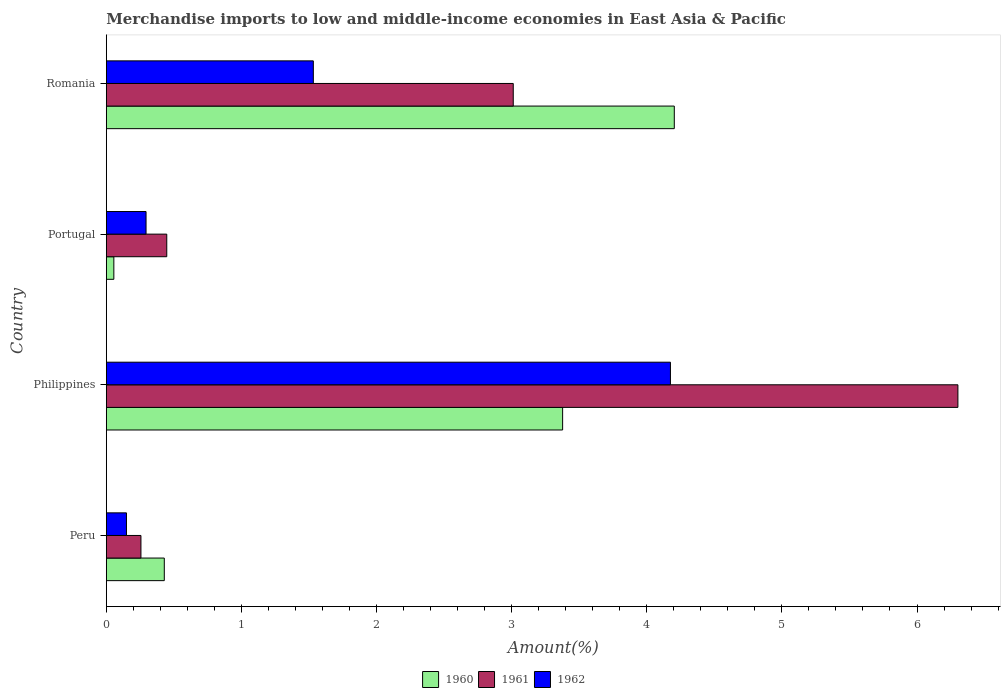How many different coloured bars are there?
Provide a short and direct response. 3. How many groups of bars are there?
Give a very brief answer. 4. Are the number of bars per tick equal to the number of legend labels?
Give a very brief answer. Yes. Are the number of bars on each tick of the Y-axis equal?
Your answer should be very brief. Yes. How many bars are there on the 2nd tick from the top?
Offer a terse response. 3. What is the percentage of amount earned from merchandise imports in 1961 in Philippines?
Give a very brief answer. 6.3. Across all countries, what is the maximum percentage of amount earned from merchandise imports in 1962?
Keep it short and to the point. 4.18. Across all countries, what is the minimum percentage of amount earned from merchandise imports in 1962?
Your answer should be compact. 0.15. In which country was the percentage of amount earned from merchandise imports in 1961 maximum?
Provide a short and direct response. Philippines. What is the total percentage of amount earned from merchandise imports in 1961 in the graph?
Make the answer very short. 10.02. What is the difference between the percentage of amount earned from merchandise imports in 1962 in Philippines and that in Romania?
Provide a succinct answer. 2.64. What is the difference between the percentage of amount earned from merchandise imports in 1961 in Peru and the percentage of amount earned from merchandise imports in 1962 in Portugal?
Make the answer very short. -0.04. What is the average percentage of amount earned from merchandise imports in 1960 per country?
Keep it short and to the point. 2.02. What is the difference between the percentage of amount earned from merchandise imports in 1961 and percentage of amount earned from merchandise imports in 1962 in Peru?
Your response must be concise. 0.11. What is the ratio of the percentage of amount earned from merchandise imports in 1961 in Peru to that in Philippines?
Provide a short and direct response. 0.04. Is the percentage of amount earned from merchandise imports in 1960 in Peru less than that in Philippines?
Provide a short and direct response. Yes. What is the difference between the highest and the second highest percentage of amount earned from merchandise imports in 1961?
Provide a short and direct response. 3.29. What is the difference between the highest and the lowest percentage of amount earned from merchandise imports in 1961?
Offer a very short reply. 6.05. In how many countries, is the percentage of amount earned from merchandise imports in 1960 greater than the average percentage of amount earned from merchandise imports in 1960 taken over all countries?
Make the answer very short. 2. Is the sum of the percentage of amount earned from merchandise imports in 1960 in Philippines and Romania greater than the maximum percentage of amount earned from merchandise imports in 1961 across all countries?
Offer a very short reply. Yes. How many bars are there?
Provide a short and direct response. 12. What is the difference between two consecutive major ticks on the X-axis?
Give a very brief answer. 1. Does the graph contain grids?
Offer a very short reply. No. Where does the legend appear in the graph?
Make the answer very short. Bottom center. How many legend labels are there?
Your answer should be very brief. 3. How are the legend labels stacked?
Ensure brevity in your answer.  Horizontal. What is the title of the graph?
Make the answer very short. Merchandise imports to low and middle-income economies in East Asia & Pacific. What is the label or title of the X-axis?
Provide a short and direct response. Amount(%). What is the label or title of the Y-axis?
Your answer should be very brief. Country. What is the Amount(%) of 1960 in Peru?
Provide a succinct answer. 0.43. What is the Amount(%) in 1961 in Peru?
Make the answer very short. 0.26. What is the Amount(%) in 1962 in Peru?
Make the answer very short. 0.15. What is the Amount(%) in 1960 in Philippines?
Your answer should be very brief. 3.38. What is the Amount(%) in 1961 in Philippines?
Offer a terse response. 6.3. What is the Amount(%) in 1962 in Philippines?
Offer a terse response. 4.18. What is the Amount(%) in 1960 in Portugal?
Offer a terse response. 0.06. What is the Amount(%) in 1961 in Portugal?
Offer a very short reply. 0.45. What is the Amount(%) in 1962 in Portugal?
Make the answer very short. 0.29. What is the Amount(%) in 1960 in Romania?
Your answer should be compact. 4.2. What is the Amount(%) in 1961 in Romania?
Offer a very short reply. 3.01. What is the Amount(%) in 1962 in Romania?
Provide a succinct answer. 1.53. Across all countries, what is the maximum Amount(%) in 1960?
Your answer should be compact. 4.2. Across all countries, what is the maximum Amount(%) in 1961?
Keep it short and to the point. 6.3. Across all countries, what is the maximum Amount(%) of 1962?
Ensure brevity in your answer.  4.18. Across all countries, what is the minimum Amount(%) in 1960?
Provide a succinct answer. 0.06. Across all countries, what is the minimum Amount(%) in 1961?
Keep it short and to the point. 0.26. Across all countries, what is the minimum Amount(%) in 1962?
Keep it short and to the point. 0.15. What is the total Amount(%) in 1960 in the graph?
Provide a succinct answer. 8.07. What is the total Amount(%) in 1961 in the graph?
Your answer should be compact. 10.02. What is the total Amount(%) of 1962 in the graph?
Give a very brief answer. 6.15. What is the difference between the Amount(%) of 1960 in Peru and that in Philippines?
Provide a short and direct response. -2.95. What is the difference between the Amount(%) in 1961 in Peru and that in Philippines?
Keep it short and to the point. -6.05. What is the difference between the Amount(%) of 1962 in Peru and that in Philippines?
Give a very brief answer. -4.03. What is the difference between the Amount(%) in 1960 in Peru and that in Portugal?
Offer a very short reply. 0.37. What is the difference between the Amount(%) of 1961 in Peru and that in Portugal?
Your response must be concise. -0.19. What is the difference between the Amount(%) of 1962 in Peru and that in Portugal?
Make the answer very short. -0.14. What is the difference between the Amount(%) in 1960 in Peru and that in Romania?
Give a very brief answer. -3.77. What is the difference between the Amount(%) of 1961 in Peru and that in Romania?
Your answer should be compact. -2.76. What is the difference between the Amount(%) of 1962 in Peru and that in Romania?
Provide a short and direct response. -1.38. What is the difference between the Amount(%) of 1960 in Philippines and that in Portugal?
Provide a succinct answer. 3.32. What is the difference between the Amount(%) in 1961 in Philippines and that in Portugal?
Offer a very short reply. 5.86. What is the difference between the Amount(%) of 1962 in Philippines and that in Portugal?
Give a very brief answer. 3.88. What is the difference between the Amount(%) of 1960 in Philippines and that in Romania?
Offer a very short reply. -0.83. What is the difference between the Amount(%) in 1961 in Philippines and that in Romania?
Ensure brevity in your answer.  3.29. What is the difference between the Amount(%) of 1962 in Philippines and that in Romania?
Your answer should be compact. 2.64. What is the difference between the Amount(%) in 1960 in Portugal and that in Romania?
Your answer should be very brief. -4.15. What is the difference between the Amount(%) of 1961 in Portugal and that in Romania?
Offer a very short reply. -2.56. What is the difference between the Amount(%) in 1962 in Portugal and that in Romania?
Make the answer very short. -1.24. What is the difference between the Amount(%) of 1960 in Peru and the Amount(%) of 1961 in Philippines?
Ensure brevity in your answer.  -5.87. What is the difference between the Amount(%) in 1960 in Peru and the Amount(%) in 1962 in Philippines?
Make the answer very short. -3.75. What is the difference between the Amount(%) in 1961 in Peru and the Amount(%) in 1962 in Philippines?
Make the answer very short. -3.92. What is the difference between the Amount(%) of 1960 in Peru and the Amount(%) of 1961 in Portugal?
Your answer should be very brief. -0.02. What is the difference between the Amount(%) in 1960 in Peru and the Amount(%) in 1962 in Portugal?
Keep it short and to the point. 0.14. What is the difference between the Amount(%) in 1961 in Peru and the Amount(%) in 1962 in Portugal?
Your answer should be very brief. -0.04. What is the difference between the Amount(%) in 1960 in Peru and the Amount(%) in 1961 in Romania?
Ensure brevity in your answer.  -2.58. What is the difference between the Amount(%) of 1960 in Peru and the Amount(%) of 1962 in Romania?
Keep it short and to the point. -1.1. What is the difference between the Amount(%) of 1961 in Peru and the Amount(%) of 1962 in Romania?
Offer a very short reply. -1.28. What is the difference between the Amount(%) of 1960 in Philippines and the Amount(%) of 1961 in Portugal?
Your answer should be compact. 2.93. What is the difference between the Amount(%) of 1960 in Philippines and the Amount(%) of 1962 in Portugal?
Keep it short and to the point. 3.08. What is the difference between the Amount(%) of 1961 in Philippines and the Amount(%) of 1962 in Portugal?
Your answer should be very brief. 6.01. What is the difference between the Amount(%) of 1960 in Philippines and the Amount(%) of 1961 in Romania?
Make the answer very short. 0.37. What is the difference between the Amount(%) of 1960 in Philippines and the Amount(%) of 1962 in Romania?
Your answer should be compact. 1.85. What is the difference between the Amount(%) of 1961 in Philippines and the Amount(%) of 1962 in Romania?
Offer a very short reply. 4.77. What is the difference between the Amount(%) of 1960 in Portugal and the Amount(%) of 1961 in Romania?
Provide a short and direct response. -2.96. What is the difference between the Amount(%) of 1960 in Portugal and the Amount(%) of 1962 in Romania?
Keep it short and to the point. -1.48. What is the difference between the Amount(%) of 1961 in Portugal and the Amount(%) of 1962 in Romania?
Keep it short and to the point. -1.08. What is the average Amount(%) in 1960 per country?
Ensure brevity in your answer.  2.02. What is the average Amount(%) of 1961 per country?
Provide a short and direct response. 2.5. What is the average Amount(%) in 1962 per country?
Your answer should be compact. 1.54. What is the difference between the Amount(%) of 1960 and Amount(%) of 1961 in Peru?
Keep it short and to the point. 0.17. What is the difference between the Amount(%) of 1960 and Amount(%) of 1962 in Peru?
Keep it short and to the point. 0.28. What is the difference between the Amount(%) in 1961 and Amount(%) in 1962 in Peru?
Ensure brevity in your answer.  0.11. What is the difference between the Amount(%) of 1960 and Amount(%) of 1961 in Philippines?
Offer a very short reply. -2.93. What is the difference between the Amount(%) in 1960 and Amount(%) in 1962 in Philippines?
Your answer should be compact. -0.8. What is the difference between the Amount(%) in 1961 and Amount(%) in 1962 in Philippines?
Ensure brevity in your answer.  2.13. What is the difference between the Amount(%) in 1960 and Amount(%) in 1961 in Portugal?
Make the answer very short. -0.39. What is the difference between the Amount(%) in 1960 and Amount(%) in 1962 in Portugal?
Offer a very short reply. -0.24. What is the difference between the Amount(%) in 1961 and Amount(%) in 1962 in Portugal?
Ensure brevity in your answer.  0.15. What is the difference between the Amount(%) of 1960 and Amount(%) of 1961 in Romania?
Give a very brief answer. 1.19. What is the difference between the Amount(%) in 1960 and Amount(%) in 1962 in Romania?
Provide a short and direct response. 2.67. What is the difference between the Amount(%) of 1961 and Amount(%) of 1962 in Romania?
Provide a succinct answer. 1.48. What is the ratio of the Amount(%) in 1960 in Peru to that in Philippines?
Ensure brevity in your answer.  0.13. What is the ratio of the Amount(%) of 1961 in Peru to that in Philippines?
Keep it short and to the point. 0.04. What is the ratio of the Amount(%) of 1962 in Peru to that in Philippines?
Your answer should be compact. 0.04. What is the ratio of the Amount(%) in 1960 in Peru to that in Portugal?
Your answer should be compact. 7.71. What is the ratio of the Amount(%) in 1961 in Peru to that in Portugal?
Your answer should be compact. 0.57. What is the ratio of the Amount(%) in 1962 in Peru to that in Portugal?
Your answer should be very brief. 0.51. What is the ratio of the Amount(%) of 1960 in Peru to that in Romania?
Your answer should be compact. 0.1. What is the ratio of the Amount(%) of 1961 in Peru to that in Romania?
Offer a very short reply. 0.09. What is the ratio of the Amount(%) of 1962 in Peru to that in Romania?
Make the answer very short. 0.1. What is the ratio of the Amount(%) in 1960 in Philippines to that in Portugal?
Your answer should be compact. 60.74. What is the ratio of the Amount(%) of 1961 in Philippines to that in Portugal?
Make the answer very short. 14.09. What is the ratio of the Amount(%) in 1962 in Philippines to that in Portugal?
Offer a very short reply. 14.2. What is the ratio of the Amount(%) of 1960 in Philippines to that in Romania?
Give a very brief answer. 0.8. What is the ratio of the Amount(%) of 1961 in Philippines to that in Romania?
Provide a short and direct response. 2.09. What is the ratio of the Amount(%) of 1962 in Philippines to that in Romania?
Provide a succinct answer. 2.73. What is the ratio of the Amount(%) of 1960 in Portugal to that in Romania?
Make the answer very short. 0.01. What is the ratio of the Amount(%) in 1961 in Portugal to that in Romania?
Your answer should be very brief. 0.15. What is the ratio of the Amount(%) of 1962 in Portugal to that in Romania?
Make the answer very short. 0.19. What is the difference between the highest and the second highest Amount(%) in 1960?
Your response must be concise. 0.83. What is the difference between the highest and the second highest Amount(%) of 1961?
Make the answer very short. 3.29. What is the difference between the highest and the second highest Amount(%) in 1962?
Give a very brief answer. 2.64. What is the difference between the highest and the lowest Amount(%) in 1960?
Ensure brevity in your answer.  4.15. What is the difference between the highest and the lowest Amount(%) in 1961?
Your response must be concise. 6.05. What is the difference between the highest and the lowest Amount(%) of 1962?
Ensure brevity in your answer.  4.03. 